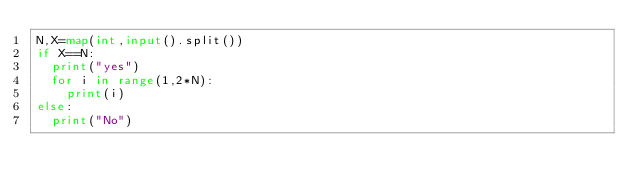<code> <loc_0><loc_0><loc_500><loc_500><_Python_>N,X=map(int,input().split())
if X==N:
  print("yes")
  for i in range(1,2*N):
    print(i)
else:
  print("No")</code> 